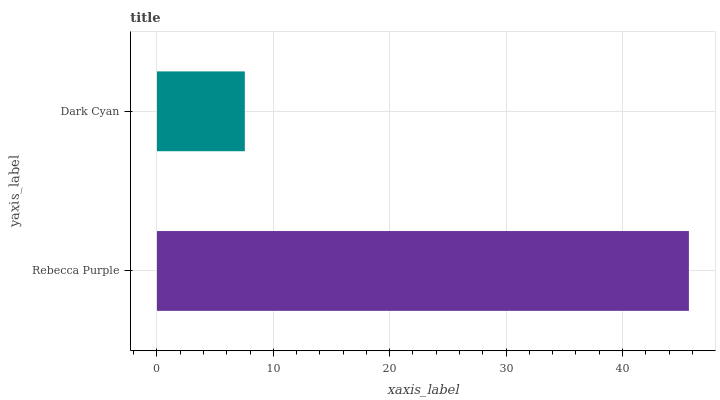Is Dark Cyan the minimum?
Answer yes or no. Yes. Is Rebecca Purple the maximum?
Answer yes or no. Yes. Is Dark Cyan the maximum?
Answer yes or no. No. Is Rebecca Purple greater than Dark Cyan?
Answer yes or no. Yes. Is Dark Cyan less than Rebecca Purple?
Answer yes or no. Yes. Is Dark Cyan greater than Rebecca Purple?
Answer yes or no. No. Is Rebecca Purple less than Dark Cyan?
Answer yes or no. No. Is Rebecca Purple the high median?
Answer yes or no. Yes. Is Dark Cyan the low median?
Answer yes or no. Yes. Is Dark Cyan the high median?
Answer yes or no. No. Is Rebecca Purple the low median?
Answer yes or no. No. 